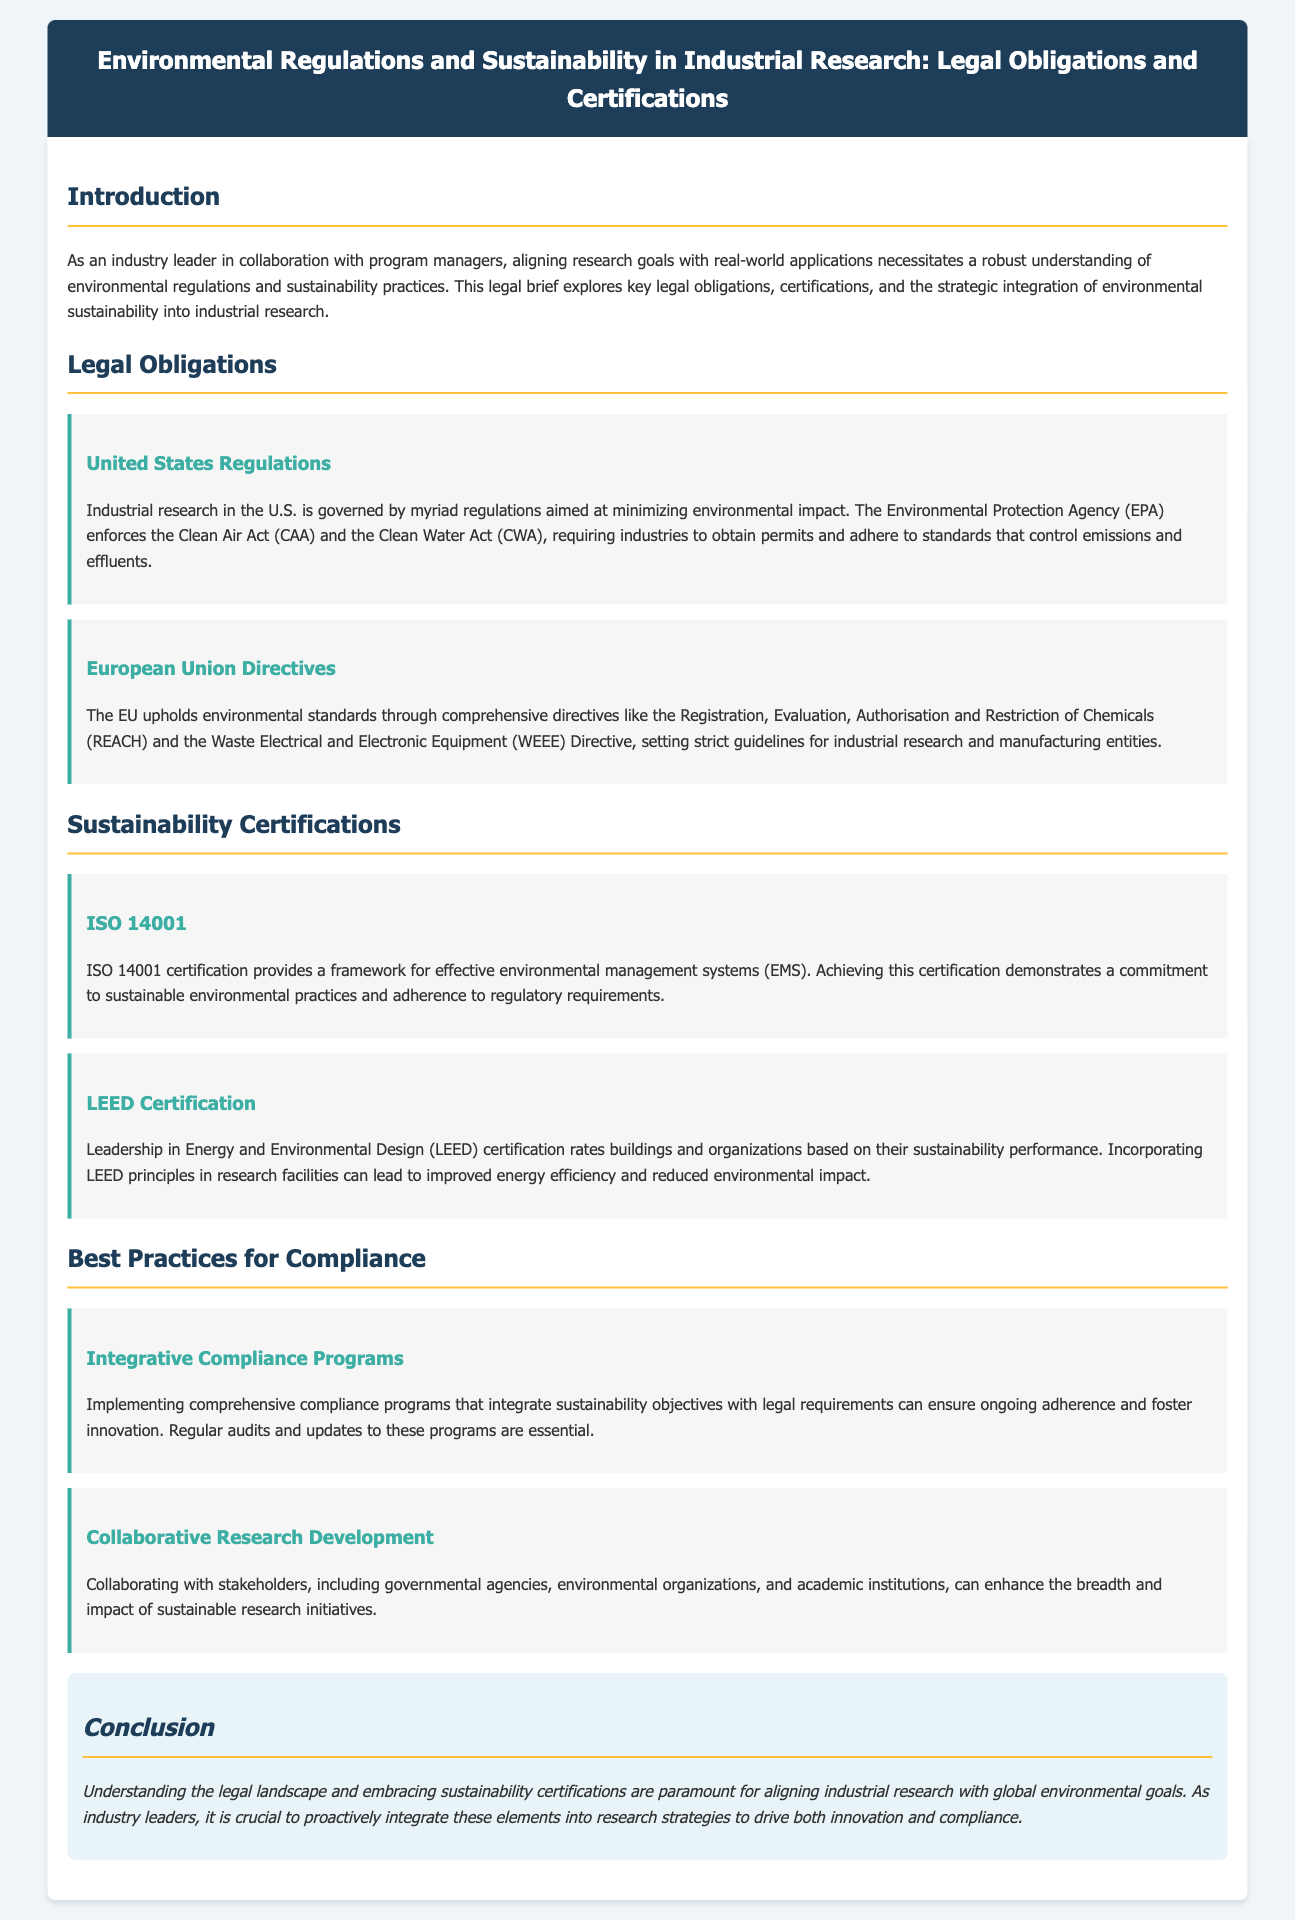What governing body enforces the Clean Air Act? The Clean Air Act is enforced by the Environmental Protection Agency (EPA).
Answer: Environmental Protection Agency Which certification framework focuses on environmental management systems? ISO 14001 certification provides a framework for effective environmental management systems (EMS).
Answer: ISO 14001 What does LEED stand for? LEED stands for Leadership in Energy and Environmental Design.
Answer: Leadership in Energy and Environmental Design What is a key aspect of best practices for compliance mentioned? Implementing comprehensive compliance programs that integrate sustainability objectives with legal requirements is a key aspect.
Answer: Integrative Compliance Programs What type of regulation does the EU utilize for environmental standards? The EU uses comprehensive directives, including the Registration, Evaluation, Authorisation and Restriction of Chemicals (REACH).
Answer: Directives Which act requires industries to obtain permits and adhere to standards? The Clean Water Act (CWA) requires industries to obtain permits and adhere to standards controlling effluents.
Answer: Clean Water Act What strategic approach is suggested for enhancing sustainable research initiatives? Collaborating with stakeholders, including governmental agencies, is suggested for enhancing sustainable research initiatives.
Answer: Collaborative Research Development What is the overall importance of understanding legal obligations and sustainability certifications? Understanding these elements is paramount for aligning industrial research with global environmental goals.
Answer: Paramount 